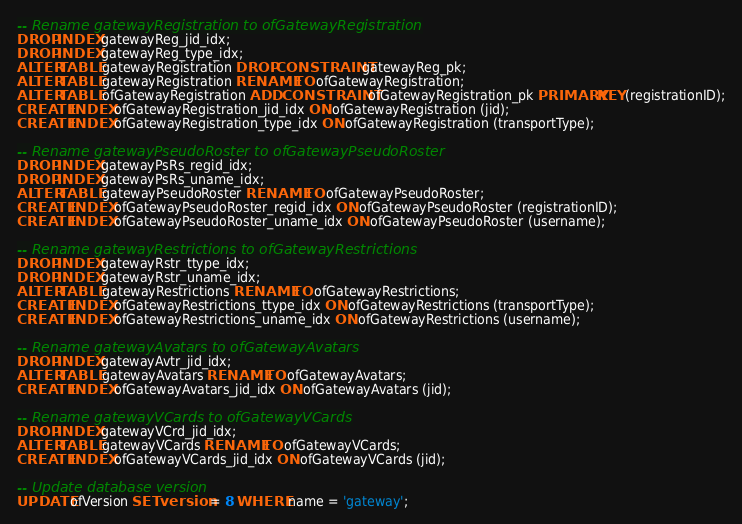Convert code to text. <code><loc_0><loc_0><loc_500><loc_500><_SQL_>-- Rename gatewayRegistration to ofGatewayRegistration
DROP INDEX gatewayReg_jid_idx;
DROP INDEX gatewayReg_type_idx;
ALTER TABLE gatewayRegistration DROP CONSTRAINT gatewayReg_pk;
ALTER TABLE gatewayRegistration RENAME TO ofGatewayRegistration;
ALTER TABLE ofGatewayRegistration ADD CONSTRAINT ofGatewayRegistration_pk PRIMARY KEY (registrationID);
CREATE INDEX ofGatewayRegistration_jid_idx ON ofGatewayRegistration (jid);
CREATE INDEX ofGatewayRegistration_type_idx ON ofGatewayRegistration (transportType);

-- Rename gatewayPseudoRoster to ofGatewayPseudoRoster
DROP INDEX gatewayPsRs_regid_idx;
DROP INDEX gatewayPsRs_uname_idx;
ALTER TABLE gatewayPseudoRoster RENAME TO ofGatewayPseudoRoster;
CREATE INDEX ofGatewayPseudoRoster_regid_idx ON ofGatewayPseudoRoster (registrationID);
CREATE INDEX ofGatewayPseudoRoster_uname_idx ON ofGatewayPseudoRoster (username);

-- Rename gatewayRestrictions to ofGatewayRestrictions
DROP INDEX gatewayRstr_ttype_idx;
DROP INDEX gatewayRstr_uname_idx;
ALTER TABLE gatewayRestrictions RENAME TO ofGatewayRestrictions;
CREATE INDEX ofGatewayRestrictions_ttype_idx ON ofGatewayRestrictions (transportType);
CREATE INDEX ofGatewayRestrictions_uname_idx ON ofGatewayRestrictions (username);

-- Rename gatewayAvatars to ofGatewayAvatars
DROP INDEX gatewayAvtr_jid_idx;
ALTER TABLE gatewayAvatars RENAME TO ofGatewayAvatars;
CREATE INDEX ofGatewayAvatars_jid_idx ON ofGatewayAvatars (jid);

-- Rename gatewayVCards to ofGatewayVCards
DROP INDEX gatewayVCrd_jid_idx;
ALTER TABLE gatewayVCards RENAME TO ofGatewayVCards;
CREATE INDEX ofGatewayVCards_jid_idx ON ofGatewayVCards (jid);

-- Update database version
UPDATE ofVersion SET version = 8 WHERE name = 'gateway';
</code> 